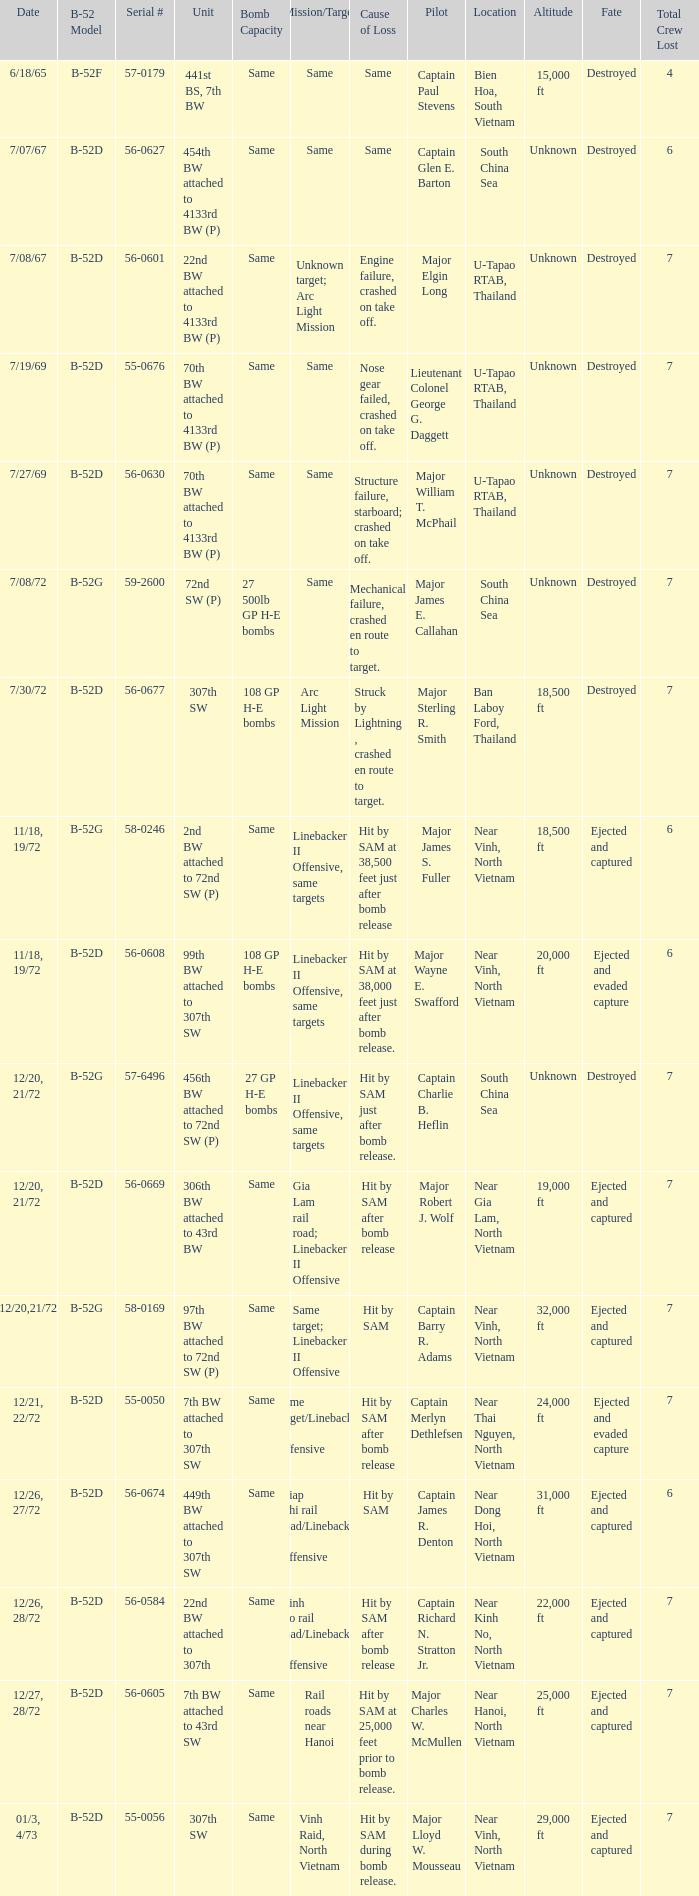Can you parse all the data within this table? {'header': ['Date', 'B-52 Model', 'Serial #', 'Unit', 'Bomb Capacity', 'Mission/Target', 'Cause of Loss', 'Pilot', 'Location', 'Altitude', 'Fate', 'Total Crew Lost'], 'rows': [['6/18/65', 'B-52F', '57-0179', '441st BS, 7th BW', 'Same', 'Same', 'Same', 'Captain Paul Stevens', 'Bien Hoa, South Vietnam', '15,000 ft', 'Destroyed', '4'], ['7/07/67', 'B-52D', '56-0627', '454th BW attached to 4133rd BW (P)', 'Same', 'Same', 'Same', 'Captain Glen E. Barton', 'South China Sea', 'Unknown', 'Destroyed', '6'], ['7/08/67', 'B-52D', '56-0601', '22nd BW attached to 4133rd BW (P)', 'Same', 'Unknown target; Arc Light Mission', 'Engine failure, crashed on take off.', 'Major Elgin Long', 'U-Tapao RTAB, Thailand', 'Unknown', 'Destroyed', '7'], ['7/19/69', 'B-52D', '55-0676', '70th BW attached to 4133rd BW (P)', 'Same', 'Same', 'Nose gear failed, crashed on take off.', 'Lieutenant Colonel George G. Daggett', 'U-Tapao RTAB, Thailand', 'Unknown', 'Destroyed', '7'], ['7/27/69', 'B-52D', '56-0630', '70th BW attached to 4133rd BW (P)', 'Same', 'Same', 'Structure failure, starboard; crashed on take off.', 'Major William T. McPhail', 'U-Tapao RTAB, Thailand', 'Unknown', 'Destroyed', '7'], ['7/08/72', 'B-52G', '59-2600', '72nd SW (P)', '27 500lb GP H-E bombs', 'Same', 'Mechanical failure, crashed en route to target.', 'Major James E. Callahan', 'South China Sea', 'Unknown', 'Destroyed', '7'], ['7/30/72', 'B-52D', '56-0677', '307th SW', '108 GP H-E bombs', 'Arc Light Mission', 'Struck by Lightning , crashed en route to target.', 'Major Sterling R. Smith', 'Ban Laboy Ford, Thailand', '18,500 ft', 'Destroyed', '7'], ['11/18, 19/72', 'B-52G', '58-0246', '2nd BW attached to 72nd SW (P)', 'Same', 'Linebacker II Offensive, same targets', 'Hit by SAM at 38,500 feet just after bomb release', 'Major James S. Fuller', 'Near Vinh, North Vietnam', '18,500 ft', 'Ejected and captured', '6'], ['11/18, 19/72', 'B-52D', '56-0608', '99th BW attached to 307th SW', '108 GP H-E bombs', 'Linebacker II Offensive, same targets', 'Hit by SAM at 38,000 feet just after bomb release.', 'Major Wayne E. Swafford', 'Near Vinh, North Vietnam', '20,000 ft', 'Ejected and evaded capture', '6'], ['12/20, 21/72', 'B-52G', '57-6496', '456th BW attached to 72nd SW (P)', '27 GP H-E bombs', 'Linebacker II Offensive, same targets', 'Hit by SAM just after bomb release.', 'Captain Charlie B. Heflin', 'South China Sea', 'Unknown', 'Destroyed', '7'], ['12/20, 21/72', 'B-52D', '56-0669', '306th BW attached to 43rd BW', 'Same', 'Gia Lam rail road; Linebacker II Offensive', 'Hit by SAM after bomb release', 'Major Robert J. Wolf', 'Near Gia Lam, North Vietnam', '19,000 ft', 'Ejected and captured', '7'], ['12/20,21/72', 'B-52G', '58-0169', '97th BW attached to 72nd SW (P)', 'Same', 'Same target; Linebacker II Offensive', 'Hit by SAM', 'Captain Barry R. Adams', 'Near Vinh, North Vietnam', '32,000 ft', 'Ejected and captured', '7'], ['12/21, 22/72', 'B-52D', '55-0050', '7th BW attached to 307th SW', 'Same', 'Same target/Linebacker II Offensive', 'Hit by SAM after bomb release', 'Captain Merlyn Dethlefsen', 'Near Thai Nguyen, North Vietnam', '24,000 ft', 'Ejected and evaded capture', '7'], ['12/26, 27/72', 'B-52D', '56-0674', '449th BW attached to 307th SW', 'Same', 'Giap Nhi rail road/Linebacker II Offensive', 'Hit by SAM', 'Captain James R. Denton', 'Near Dong Hoi, North Vietnam', '31,000 ft', 'Ejected and captured', '6'], ['12/26, 28/72', 'B-52D', '56-0584', '22nd BW attached to 307th', 'Same', 'Kinh No rail road/Linebacker II Offensive', 'Hit by SAM after bomb release', 'Captain Richard N. Stratton Jr.', 'Near Kinh No, North Vietnam', '22,000 ft', 'Ejected and captured', '7'], ['12/27, 28/72', 'B-52D', '56-0605', '7th BW attached to 43rd SW', 'Same', 'Rail roads near Hanoi', 'Hit by SAM at 25,000 feet prior to bomb release.', 'Major Charles W. McMullen', 'Near Hanoi, North Vietnam', '25,000 ft', 'Ejected and captured', '7'], ['01/3, 4/73', 'B-52D', '55-0056', '307th SW', 'Same', 'Vinh Raid, North Vietnam', 'Hit by SAM during bomb release.', 'Major Lloyd W. Mousseau', 'Near Vinh, North Vietnam', '29,000 ft', 'Ejected and captured', '7']]} When 7th bw attached to 43rd sw is the unit what is the b-52 model? B-52D. 